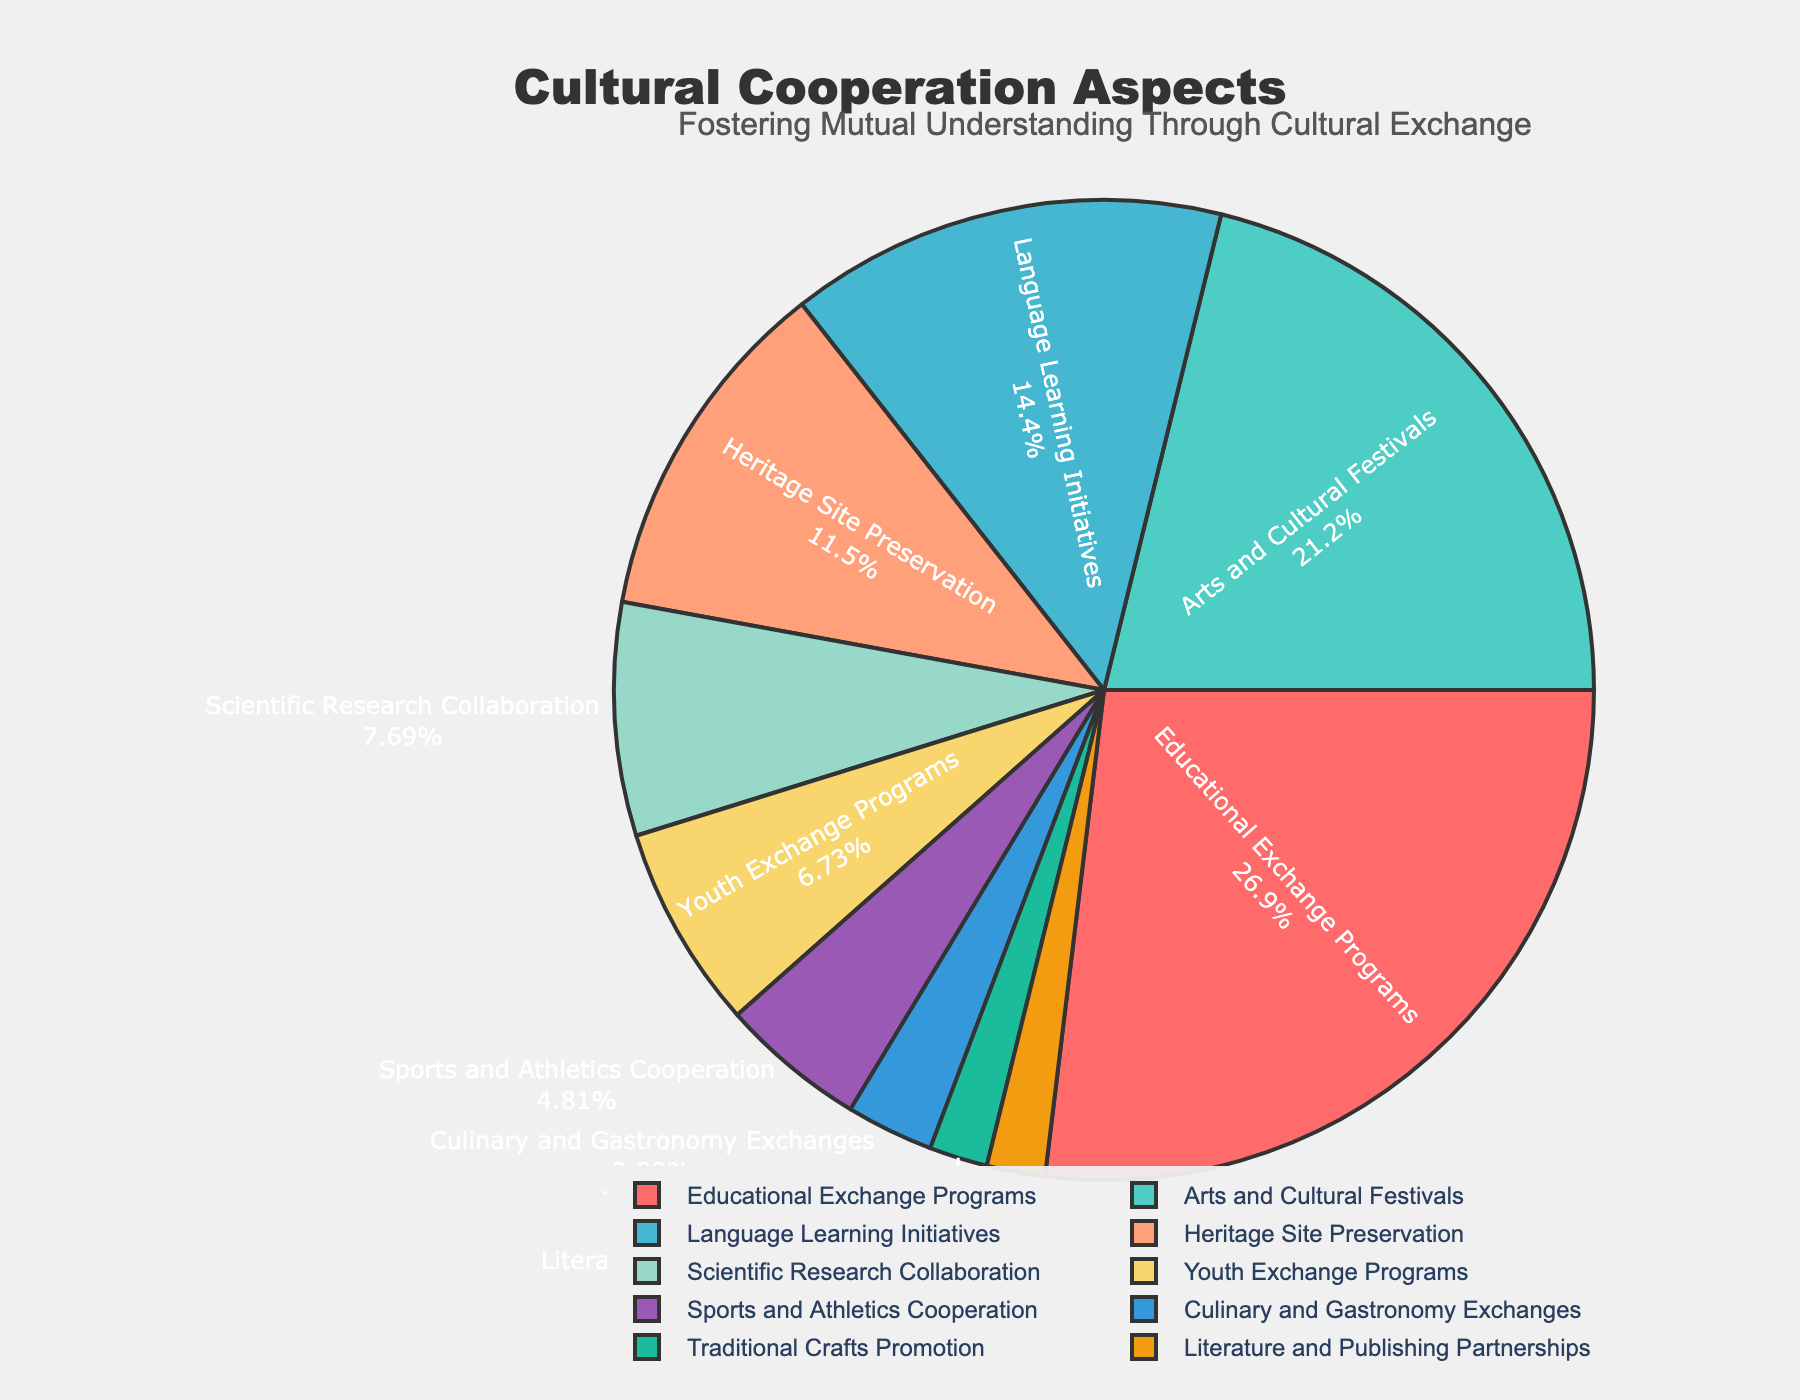What aspect has the highest percentage of bilateral agreements? The aspect with the highest percentage can be identified by looking for the largest segment. The segment labeled "Educational Exchange Programs" is the largest.
Answer: Educational Exchange Programs Which aspect has the lowest percentage of bilateral agreements? The smallest segment will indicate the aspect with the lowest percentage. The segments labeled "Traditional Crafts Promotion" and "Literature and Publishing Partnerships" are the smallest.
Answer: Traditional Crafts Promotion and Literature and Publishing Partnerships What is the total percentage of bilateral agreements focused on youth and sports? Sum the percentages of "Youth Exchange Programs" and "Sports and Athletics Cooperation". These are 7% and 5% respectively. So, 7% + 5% = 12%.
Answer: 12% Which has a greater percentage: Language Learning Initiatives or Culinary and Gastronomy Exchanges? Compare the percentages of "Language Learning Initiatives" (15%) and "Culinary and Gastronomy Exchanges" (3%). The "Language Learning Initiatives" has a greater percentage.
Answer: Language Learning Initiatives How much more percentage is dedicated to Arts and Cultural Festivals compared to Heritage Site Preservation? Subtract the percentage of "Heritage Site Preservation" from "Arts and Cultural Festivals". That is, 22% - 12% = 10%.
Answer: 10% What is the combined percentage of agreements focused on arts (Arts and Cultural Festivals) and science (Scientific Research Collaboration)? Sum the percentages of "Arts and Cultural Festivals" and "Scientific Research Collaboration". These are 22% and 8% respectively, giving 22% + 8% = 30%.
Answer: 30% Which aspect has a higher percentage: Heritage Site Preservation or Youth Exchange Programs? Compare the percentages of "Heritage Site Preservation" (12%) and "Youth Exchange Programs" (7%). "Heritage Site Preservation" has a higher percentage.
Answer: Heritage Site Preservation What percentage of bilateral agreements focuses on the traditional crafts and literature combined? Sum the percentages of "Traditional Crafts Promotion" and "Literature and Publishing Partnerships". Each is 2%, so 2% + 2% = 4%.
Answer: 4% By how much does Educational Exchange Programs exceed the percentage of Language Learning Initiatives? Subtract the percentage of "Language Learning Initiatives" (15%) from "Educational Exchange Programs" (28%). That is, 28% - 15% = 13%.
Answer: 13% Which aspect contributes less than 10% of the bilateral agreements in the figure? Identify segments with percentages less than 10%. These are "Scientific Research Collaboration" (8%), "Youth Exchange Programs" (7%), "Sports and Athletics Cooperation" (5%), "Culinary and Gastronomy Exchanges" (3%), "Traditional Crafts Promotion" (2%), and "Literature and Publishing Partnerships" (2%).
Answer: Scientific Research Collaboration, Youth Exchange Programs, Sports and Athletics Cooperation, Culinary and Gastronomy Exchanges, Traditional Crafts Promotion, and Literature and Publishing Partnerships 